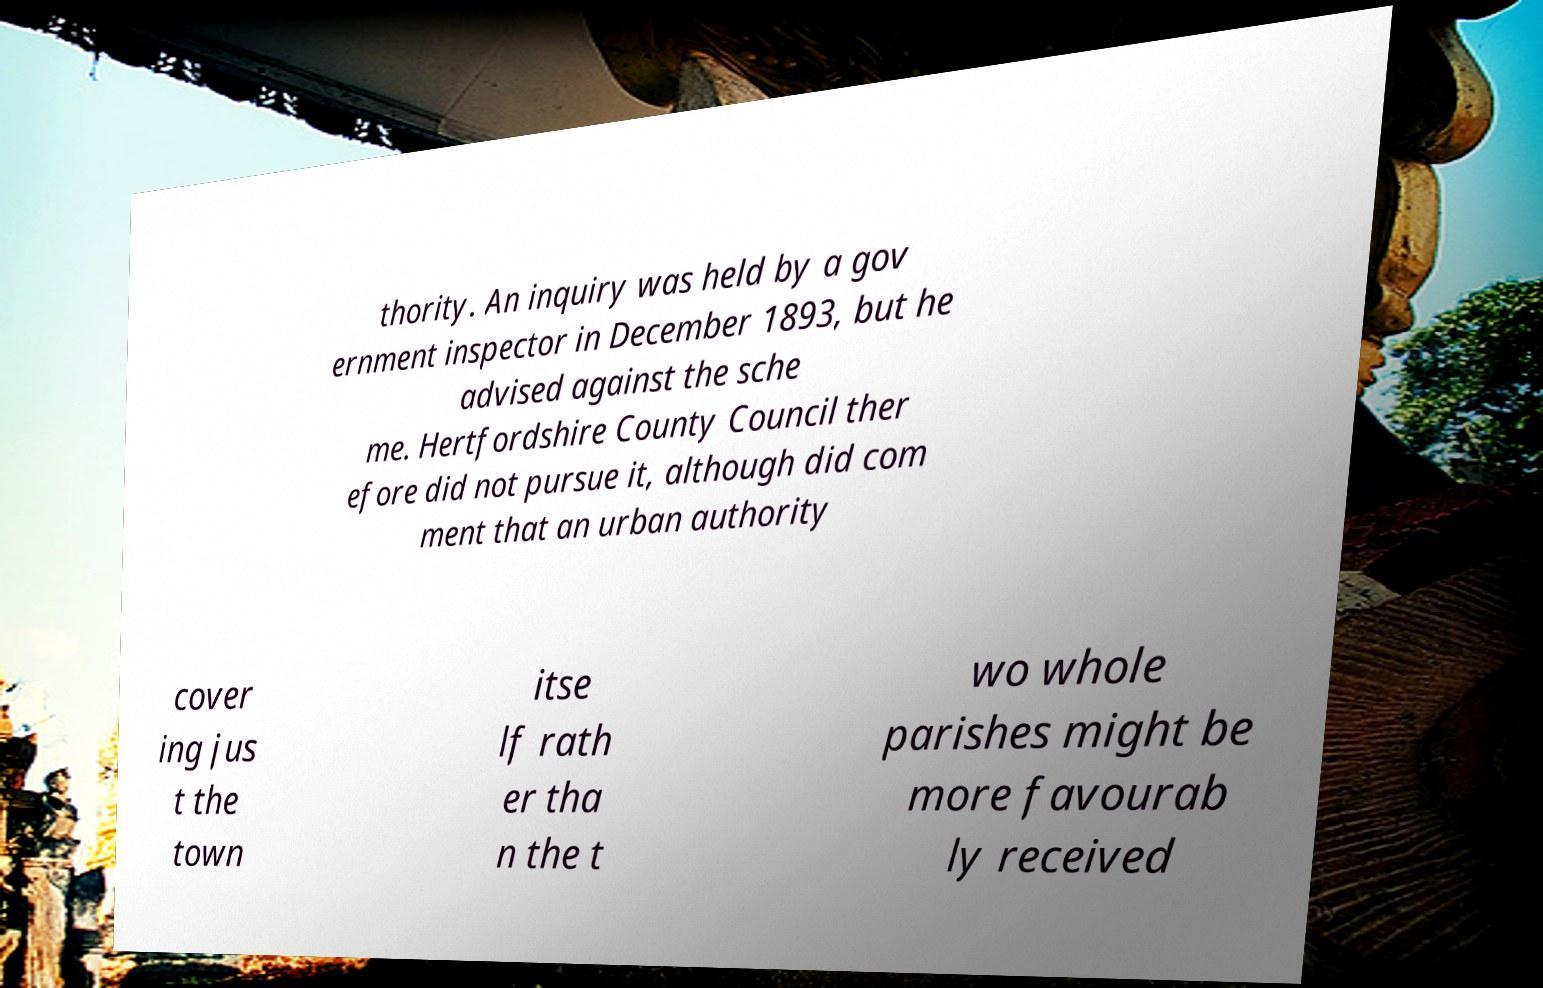What messages or text are displayed in this image? I need them in a readable, typed format. thority. An inquiry was held by a gov ernment inspector in December 1893, but he advised against the sche me. Hertfordshire County Council ther efore did not pursue it, although did com ment that an urban authority cover ing jus t the town itse lf rath er tha n the t wo whole parishes might be more favourab ly received 